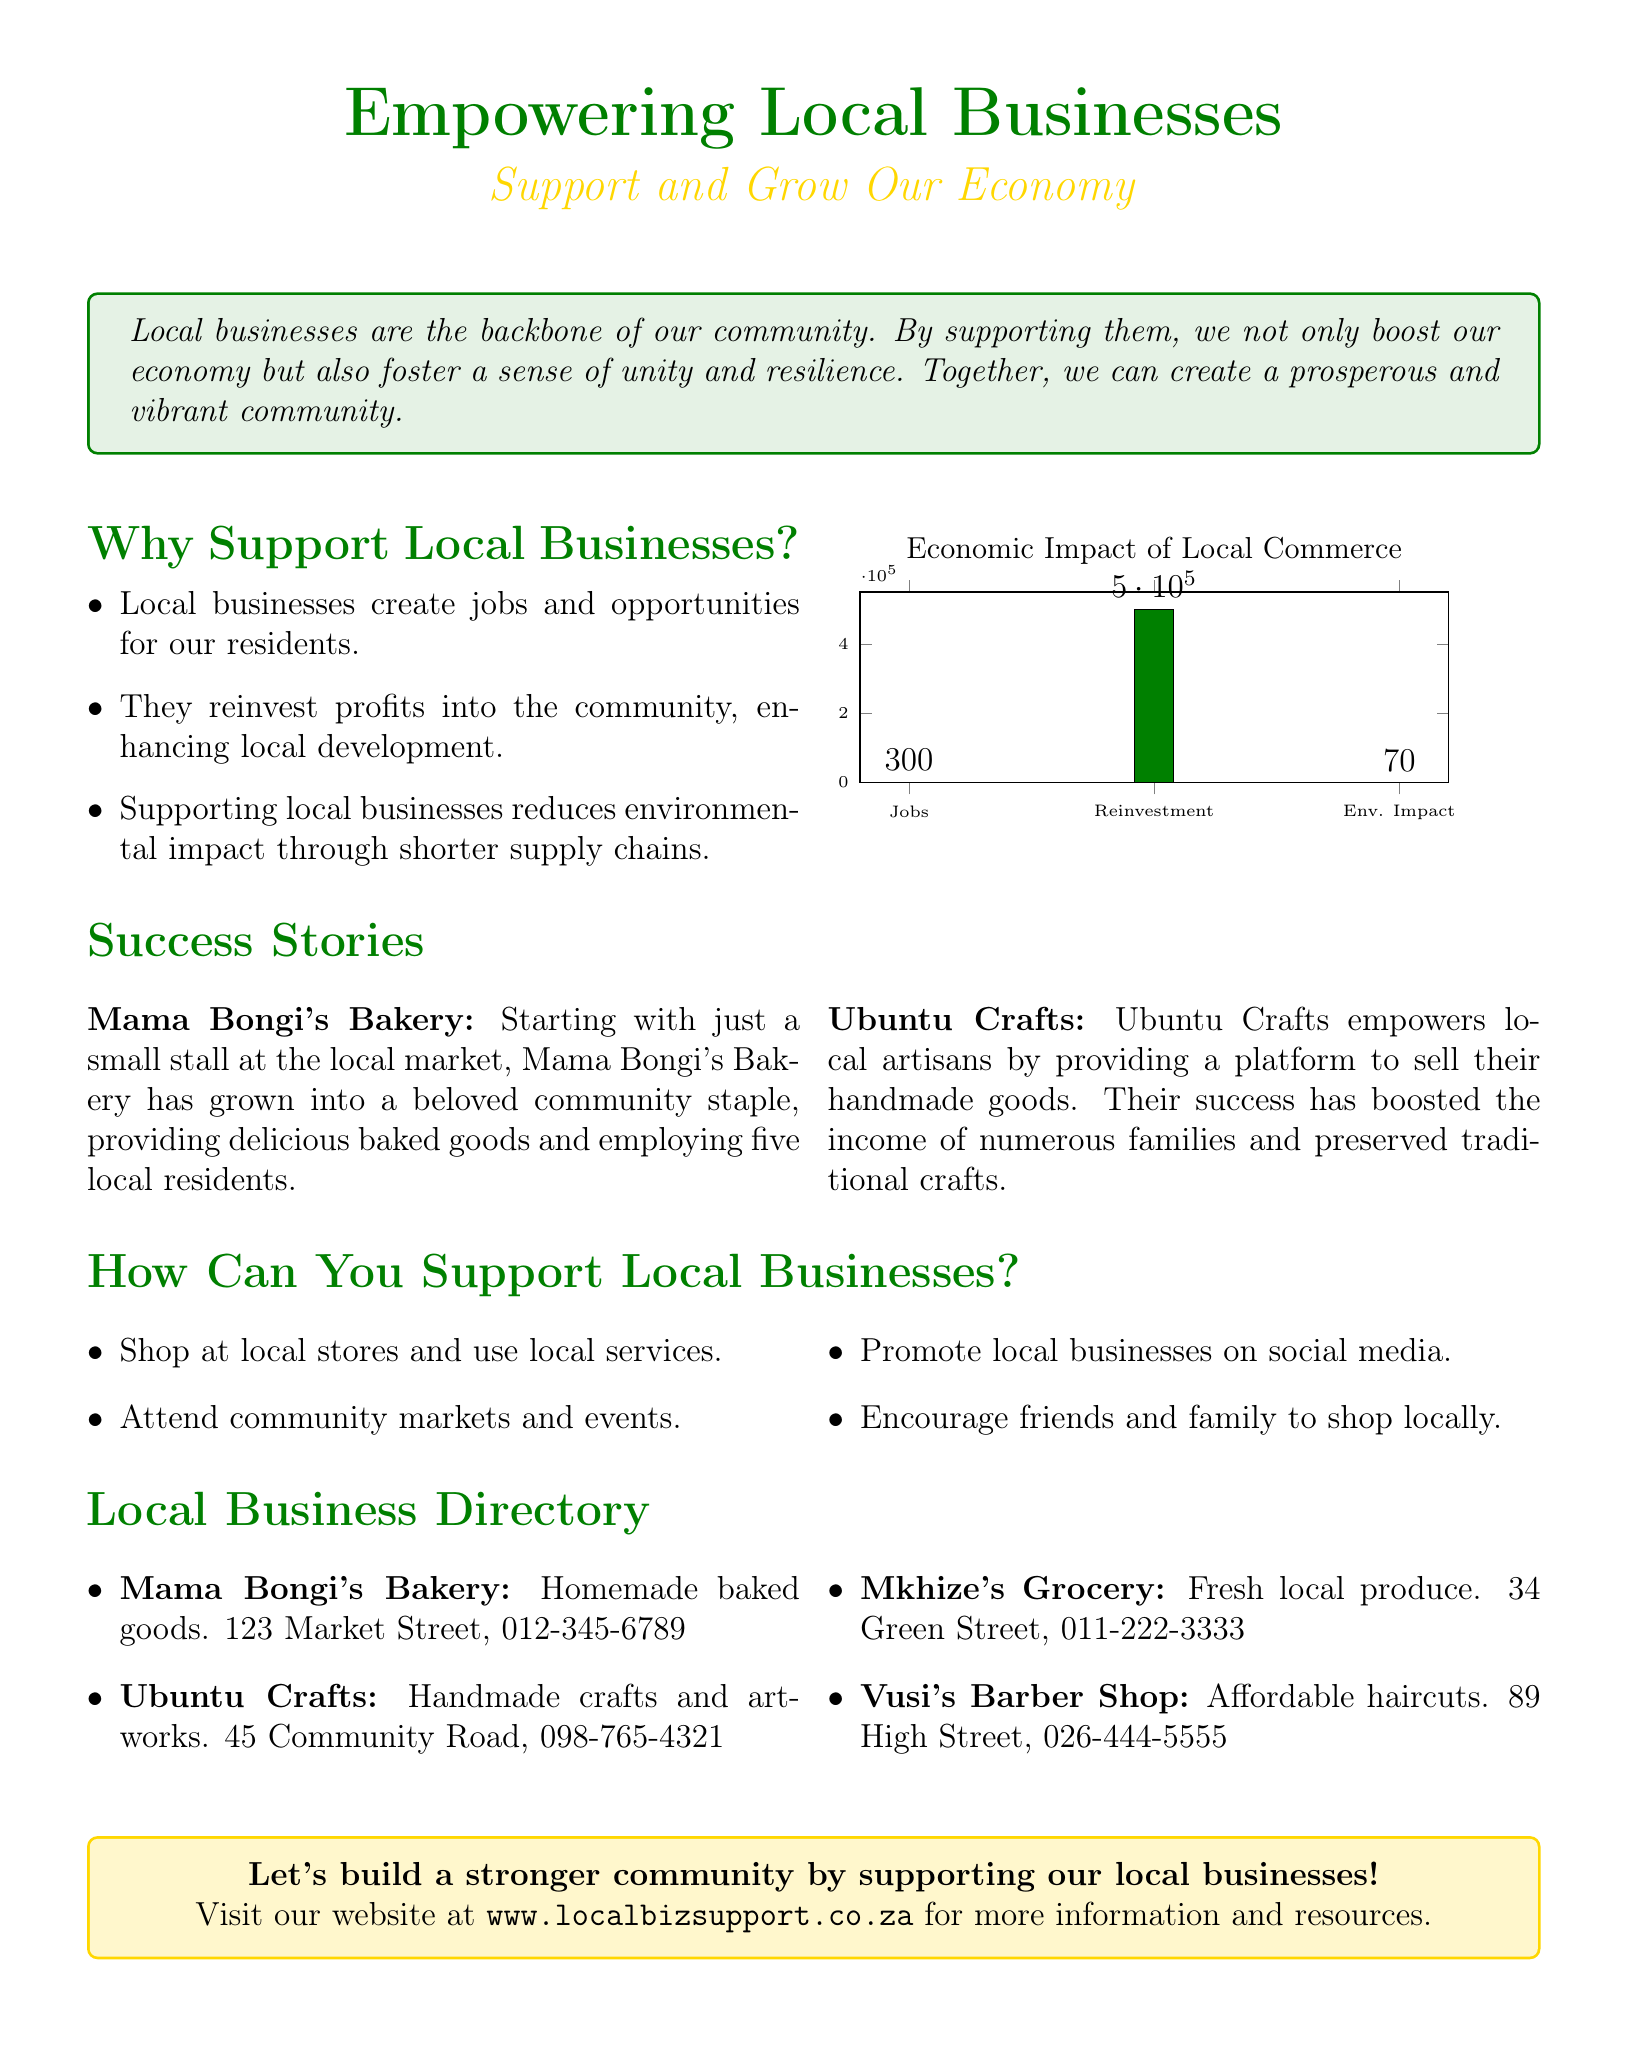What is the title of the flyer? The title is prominently presented at the top of the document.
Answer: Empowering Local Businesses How many jobs does local businesses create according to the graph? The graph provides a specific figure for job creation by local businesses.
Answer: 300 What is the address of Mama Bongi's Bakery? The document lists the address of various businesses, including Mama Bongi's Bakery.
Answer: 123 Market Street What percentage impact does local commerce have on environmental impact? The graph shows the environmental impact metric alongside other metrics.
Answer: 70 What is the primary benefit mentioned for supporting local businesses? The document outlines several reasons, including one that captures the main benefit of supporting local businesses.
Answer: Create jobs According to the success stories, what does Ubuntu Crafts empower? The success stories give insights into what local businesses do, particularly Ubuntu Crafts.
Answer: Local artisans What action can residents take to promote local businesses on social media? The document suggests actions residents can take to support local businesses, including specific social media activities.
Answer: Promote local businesses How many local businesses are listed in the directory? The directory section enumerates the businesses available in the community.
Answer: 4 What color theme is used for the title and headers in the flyer? The flyer utilizes specific colors that are characteristic of its design throughout.
Answer: African green and gold 